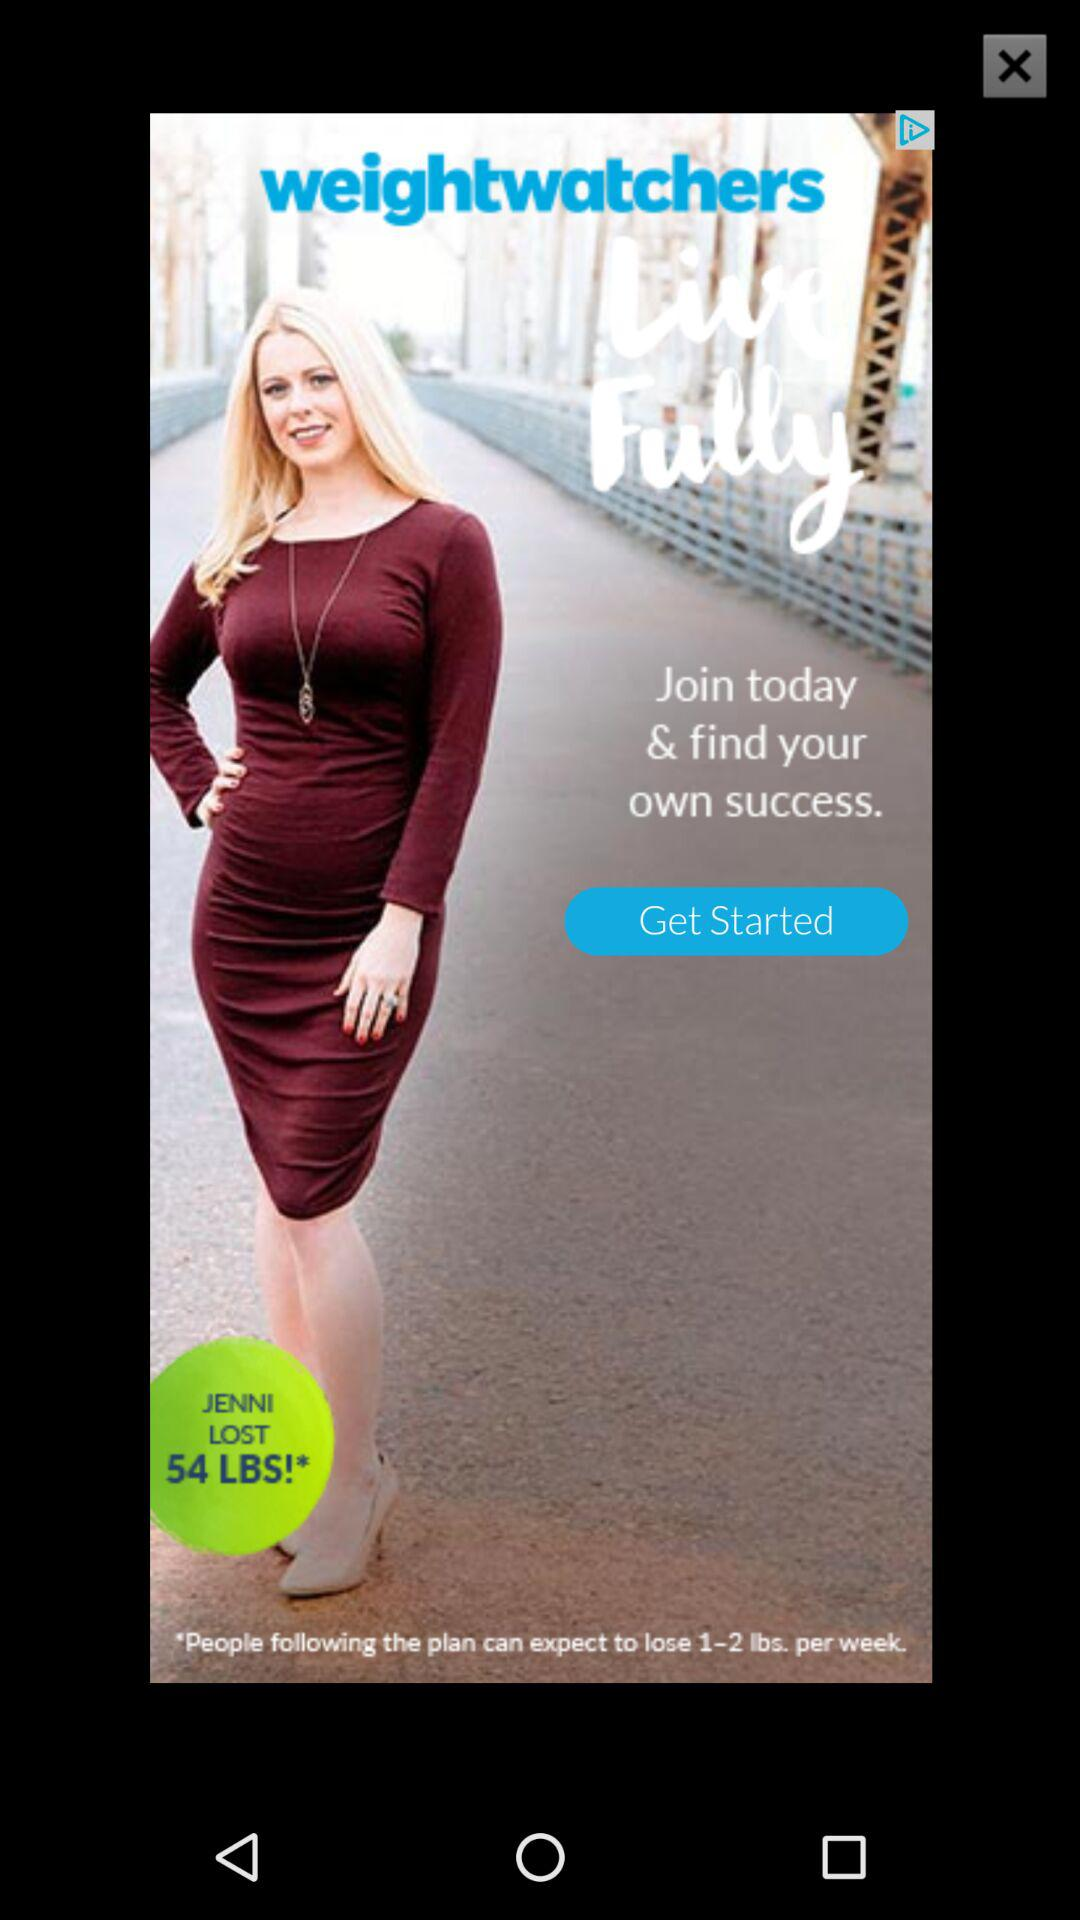How many pounds did Jenny lose?
Answer the question using a single word or phrase. 54 